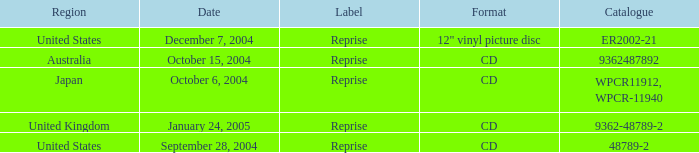Identify the region related to december 7, 2004. United States. 